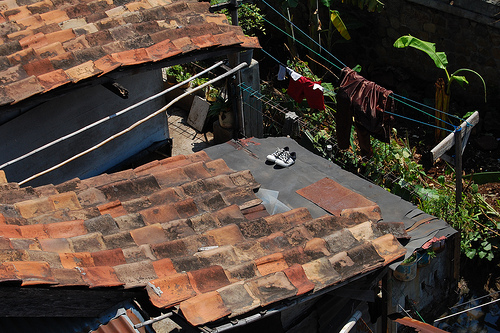<image>
Is there a rope in front of the shoes? No. The rope is not in front of the shoes. The spatial positioning shows a different relationship between these objects. 